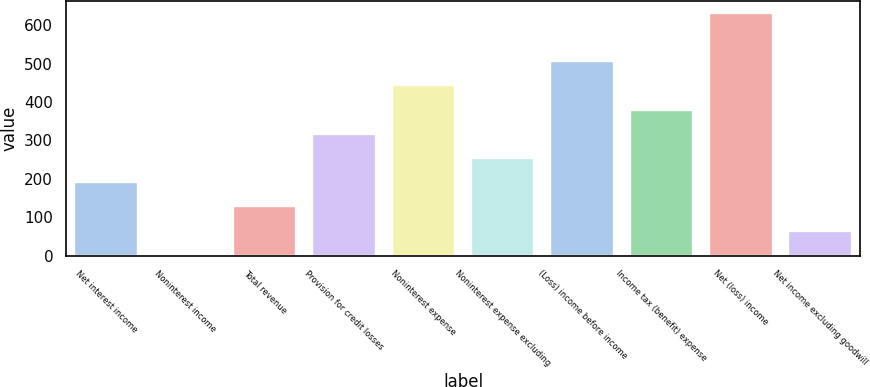Convert chart to OTSL. <chart><loc_0><loc_0><loc_500><loc_500><bar_chart><fcel>Net interest income<fcel>Noninterest income<fcel>Total revenue<fcel>Provision for credit losses<fcel>Noninterest expense<fcel>Noninterest expense excluding<fcel>(Loss) income before income<fcel>Income tax (benefit) expense<fcel>Net (loss) income<fcel>Net income excluding goodwill<nl><fcel>191.3<fcel>2<fcel>128.2<fcel>317.5<fcel>443.7<fcel>254.4<fcel>506.8<fcel>380.6<fcel>633<fcel>65.1<nl></chart> 